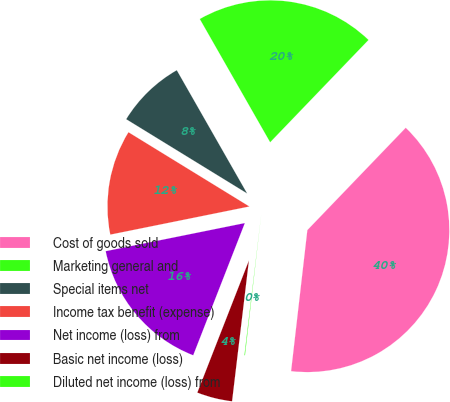<chart> <loc_0><loc_0><loc_500><loc_500><pie_chart><fcel>Cost of goods sold<fcel>Marketing general and<fcel>Special items net<fcel>Income tax benefit (expense)<fcel>Net income (loss) from<fcel>Basic net income (loss)<fcel>Diluted net income (loss) from<nl><fcel>39.64%<fcel>20.44%<fcel>7.98%<fcel>11.94%<fcel>15.9%<fcel>4.03%<fcel>0.07%<nl></chart> 